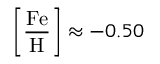<formula> <loc_0><loc_0><loc_500><loc_500>\left [ { \frac { F e } { H } } \right ] \approx - 0 . 5 0</formula> 